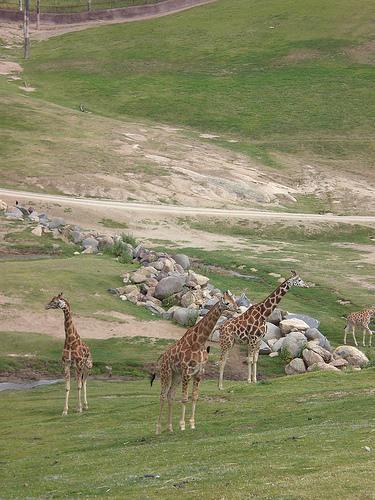How many giraffe do you see?
Give a very brief answer. 4. How many giraffes are in the left of the rocks?
Give a very brief answer. 3. 